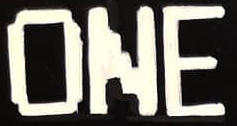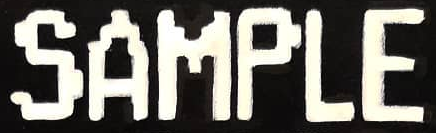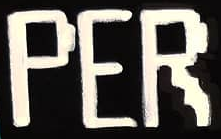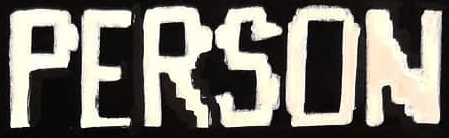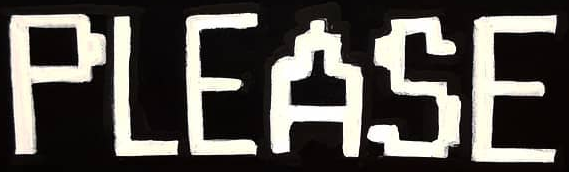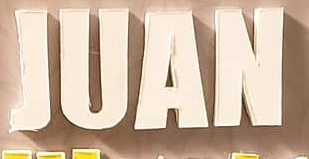What text appears in these images from left to right, separated by a semicolon? ONE; SAMPLE; PER; PERSON; PLEASE; JUAN 